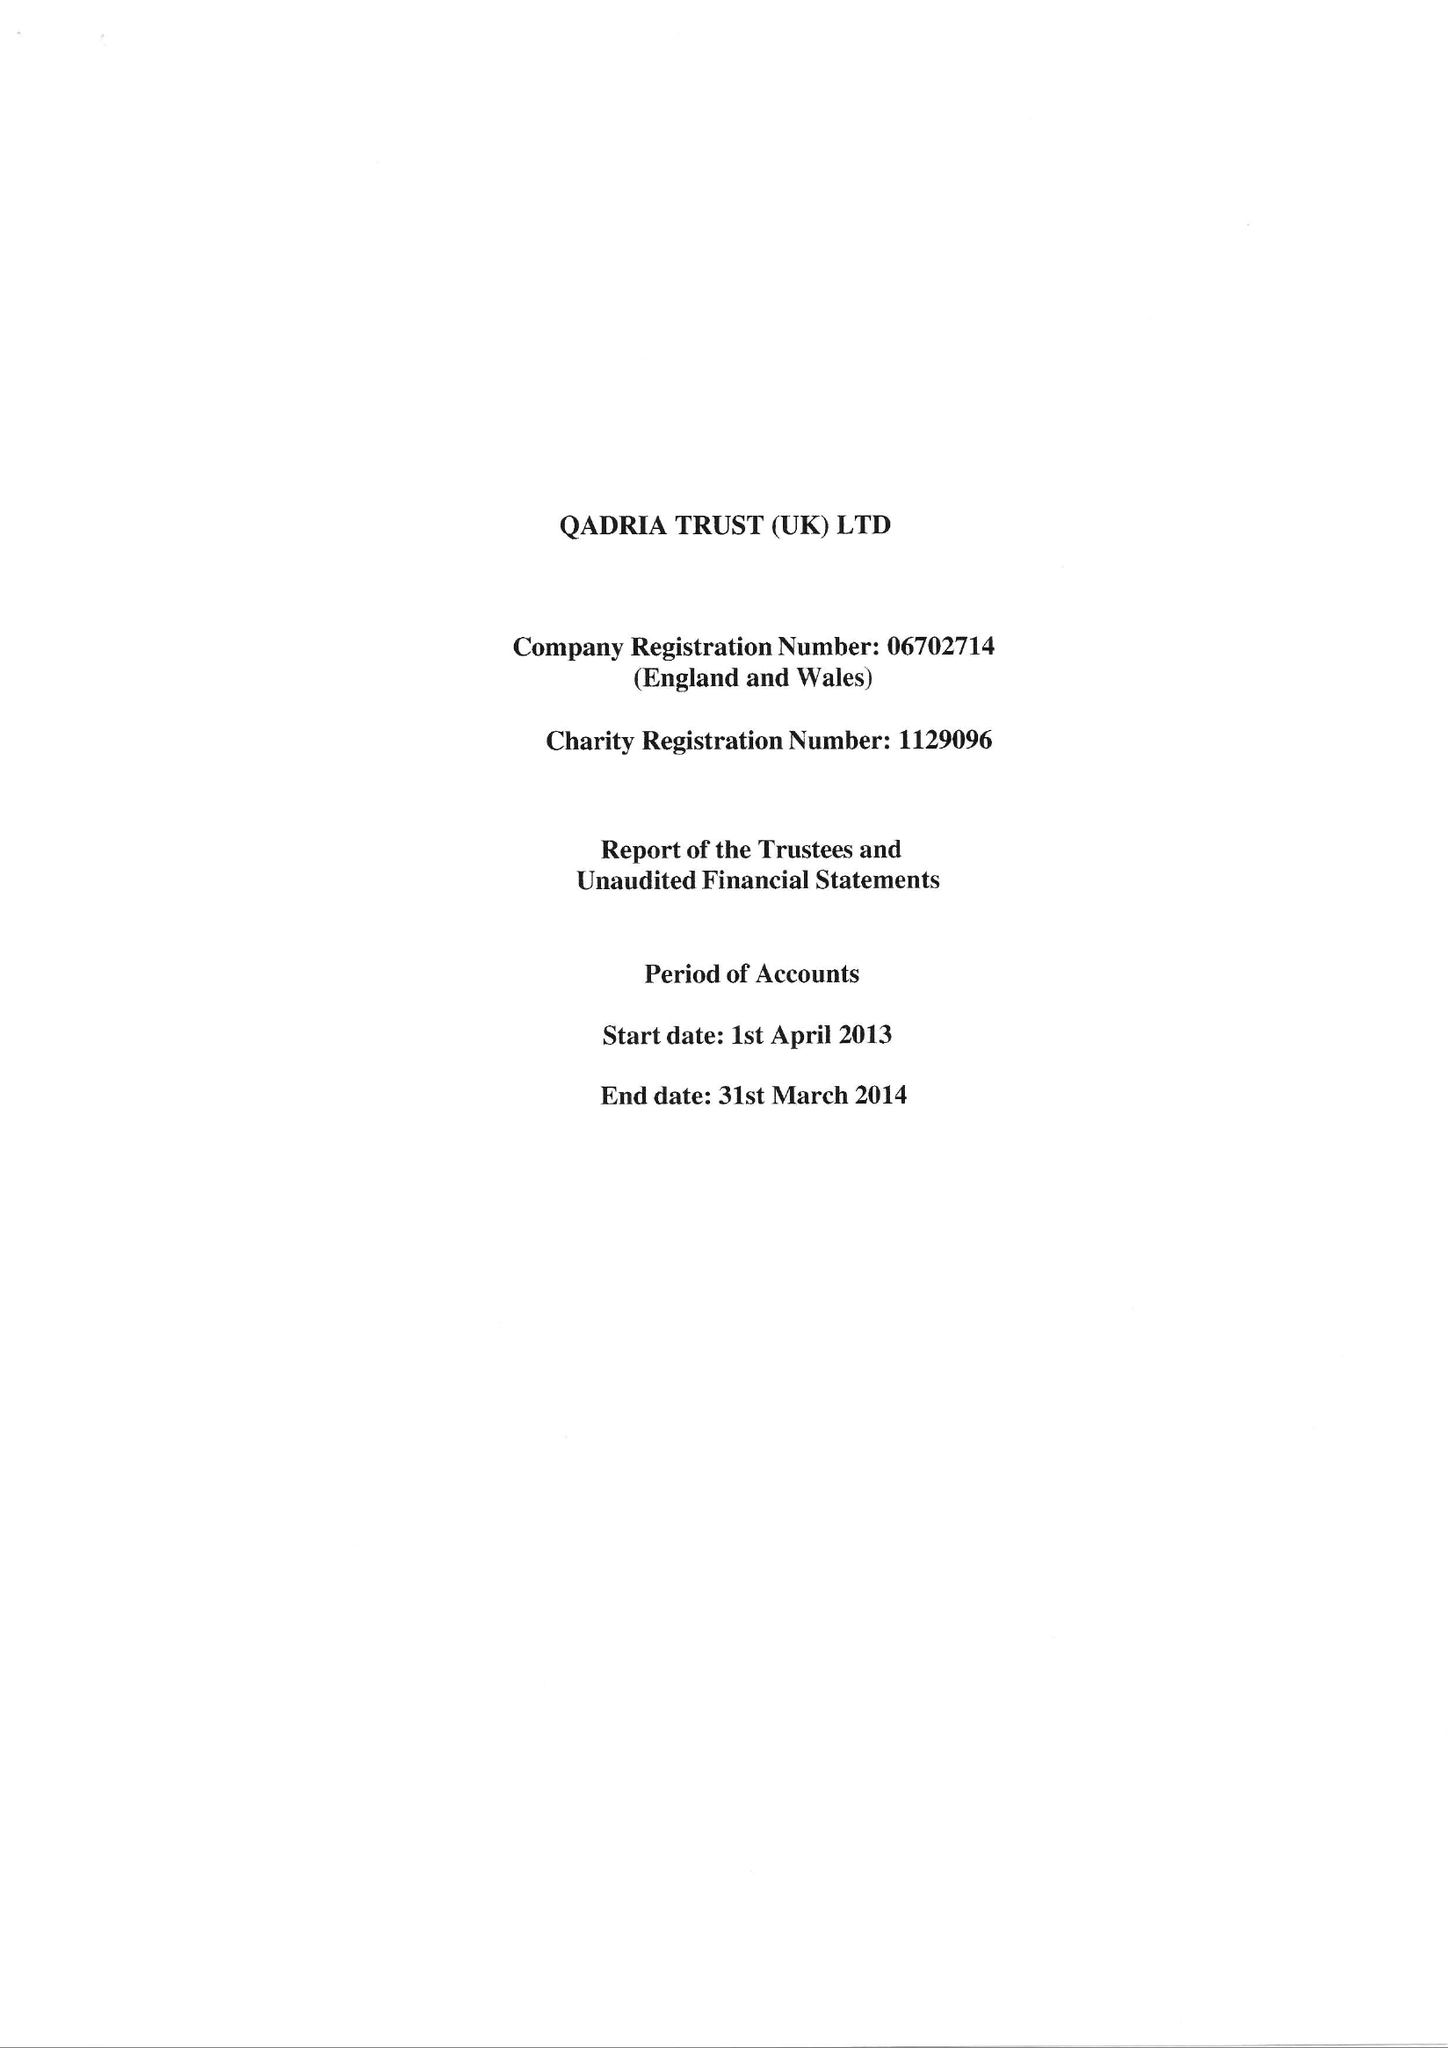What is the value for the income_annually_in_british_pounds?
Answer the question using a single word or phrase. 200691.00 